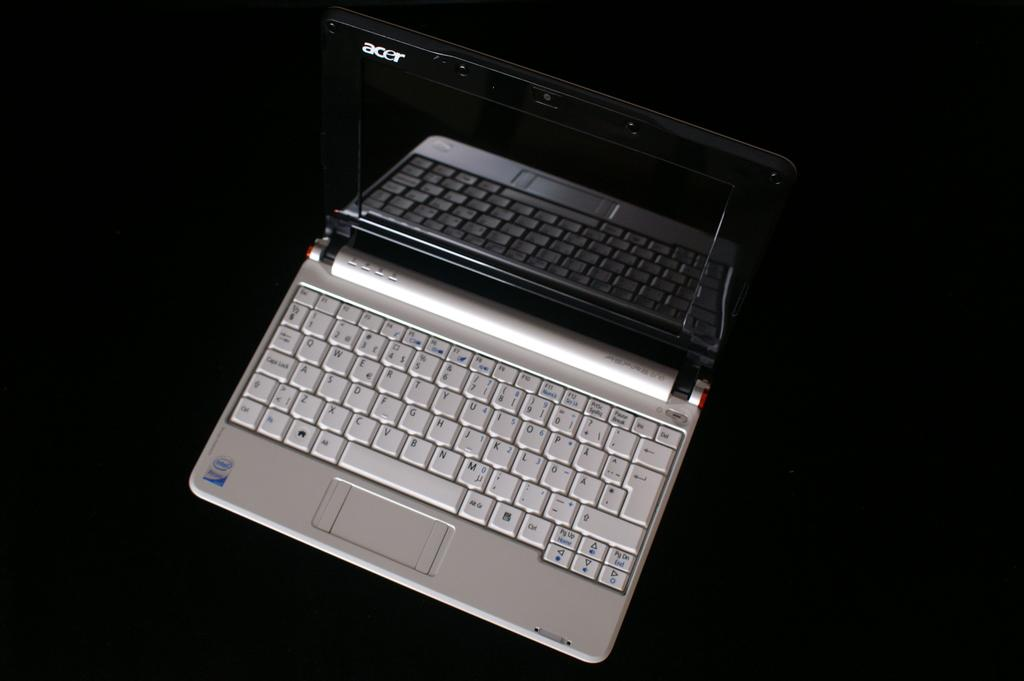<image>
Relay a brief, clear account of the picture shown. An Acer laptop that has a black monitor and silver keyboard. 